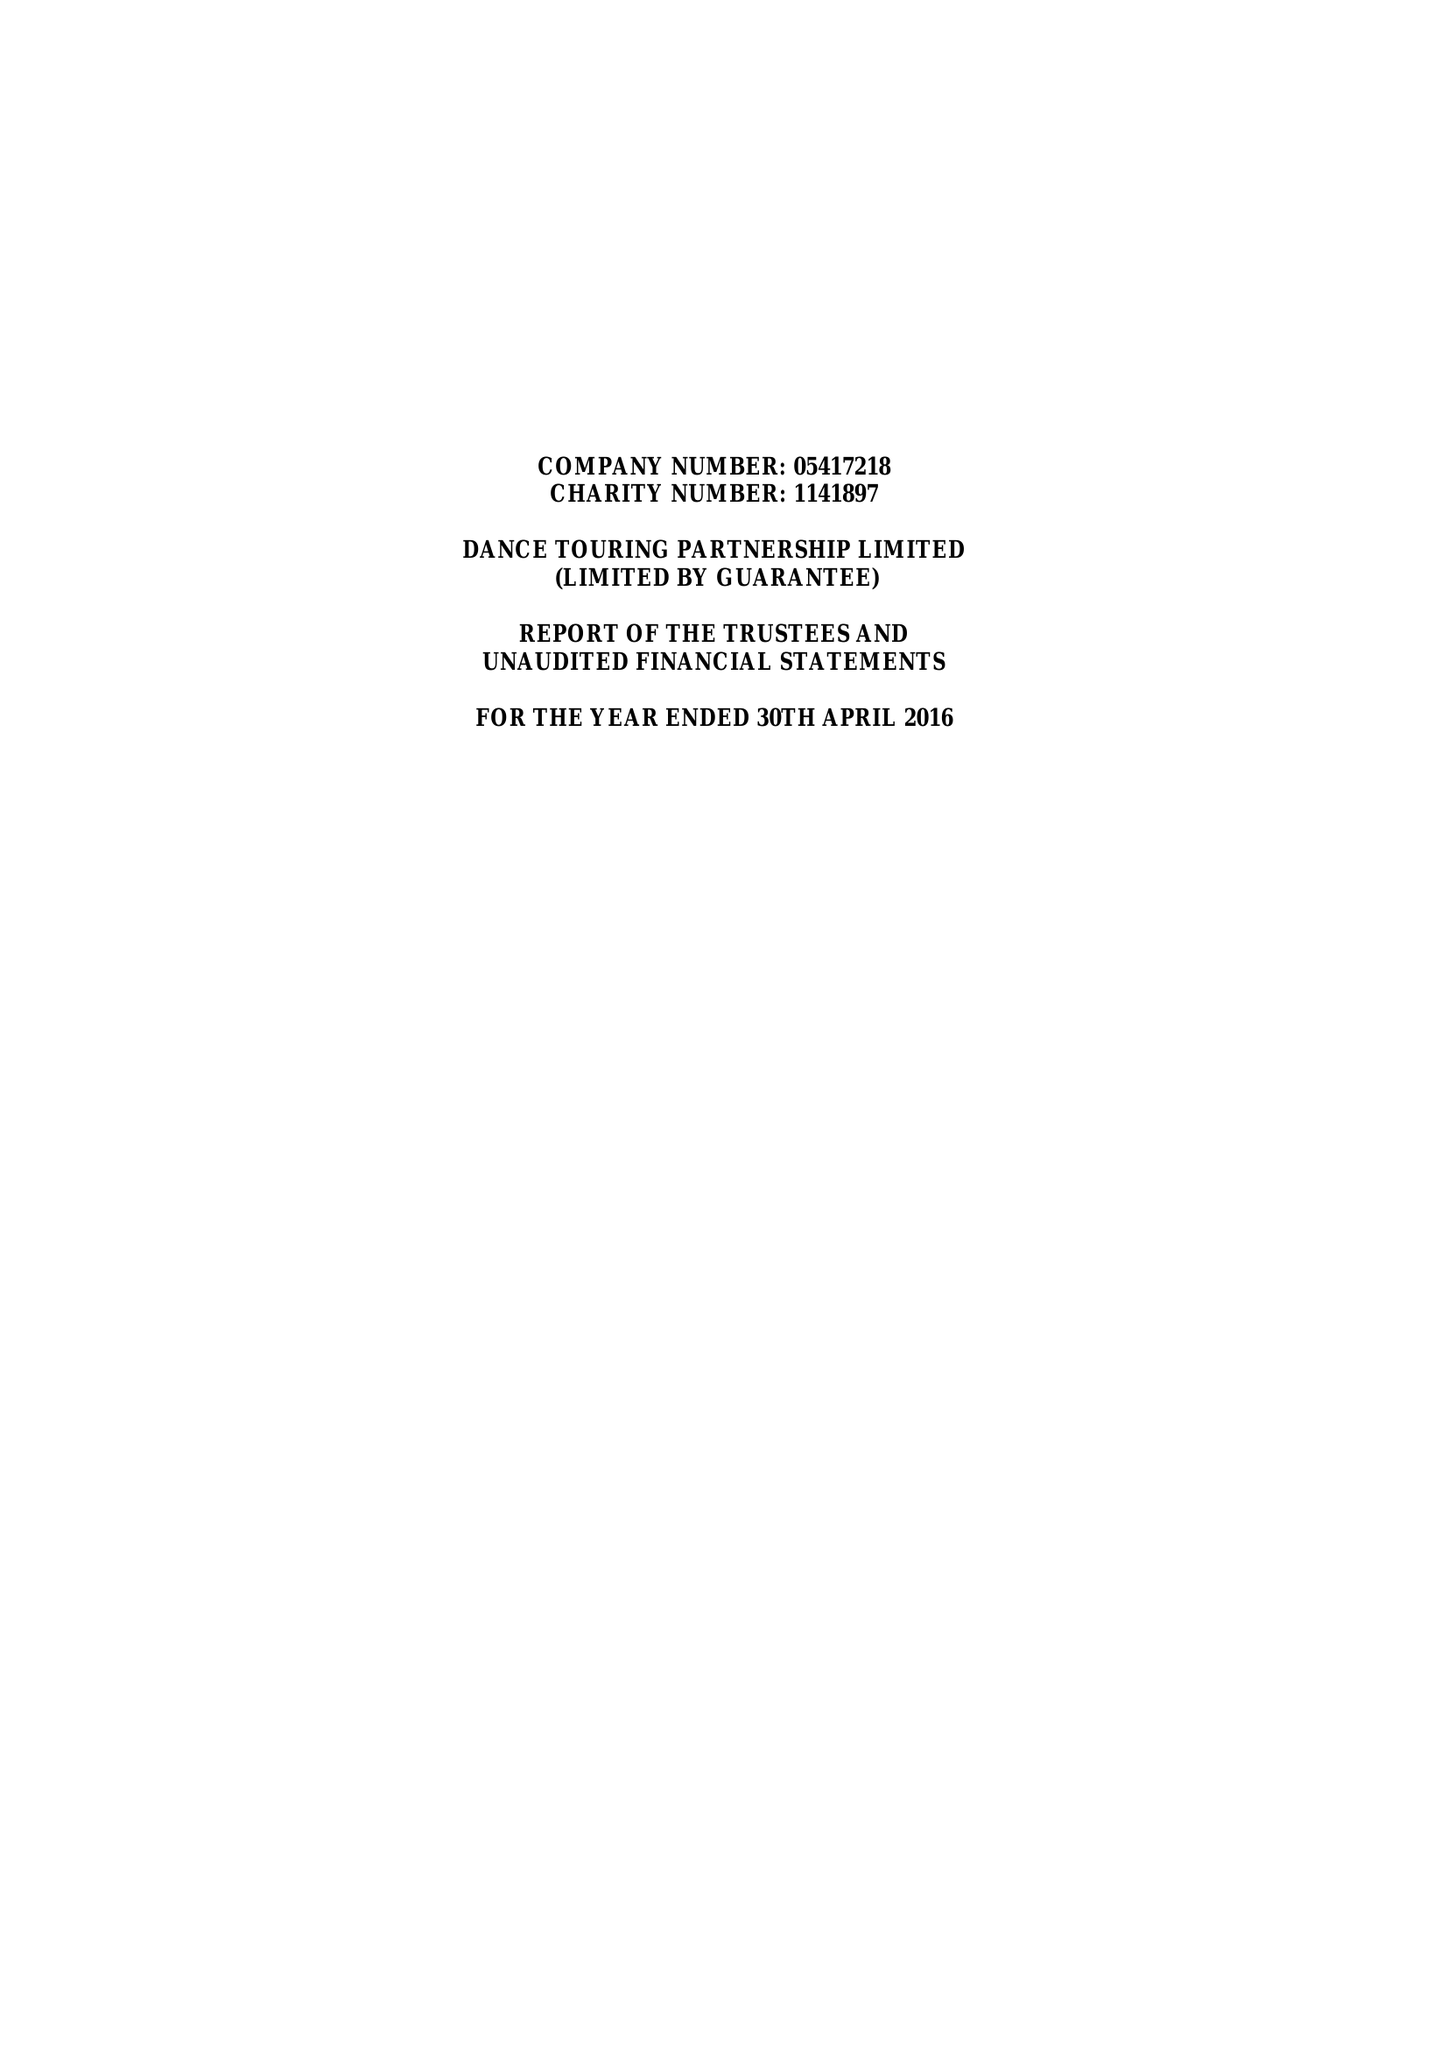What is the value for the income_annually_in_british_pounds?
Answer the question using a single word or phrase. 41080.00 